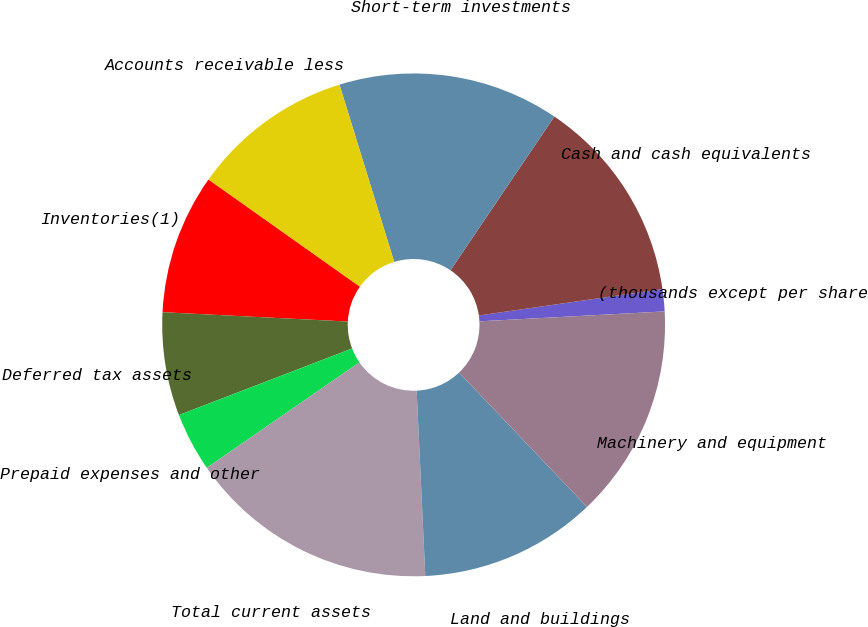<chart> <loc_0><loc_0><loc_500><loc_500><pie_chart><fcel>(thousands except per share<fcel>Cash and cash equivalents<fcel>Short-term investments<fcel>Accounts receivable less<fcel>Inventories(1)<fcel>Deferred tax assets<fcel>Prepaid expenses and other<fcel>Total current assets<fcel>Land and buildings<fcel>Machinery and equipment<nl><fcel>1.42%<fcel>13.27%<fcel>14.22%<fcel>10.43%<fcel>9.0%<fcel>6.64%<fcel>3.79%<fcel>16.11%<fcel>11.37%<fcel>13.74%<nl></chart> 